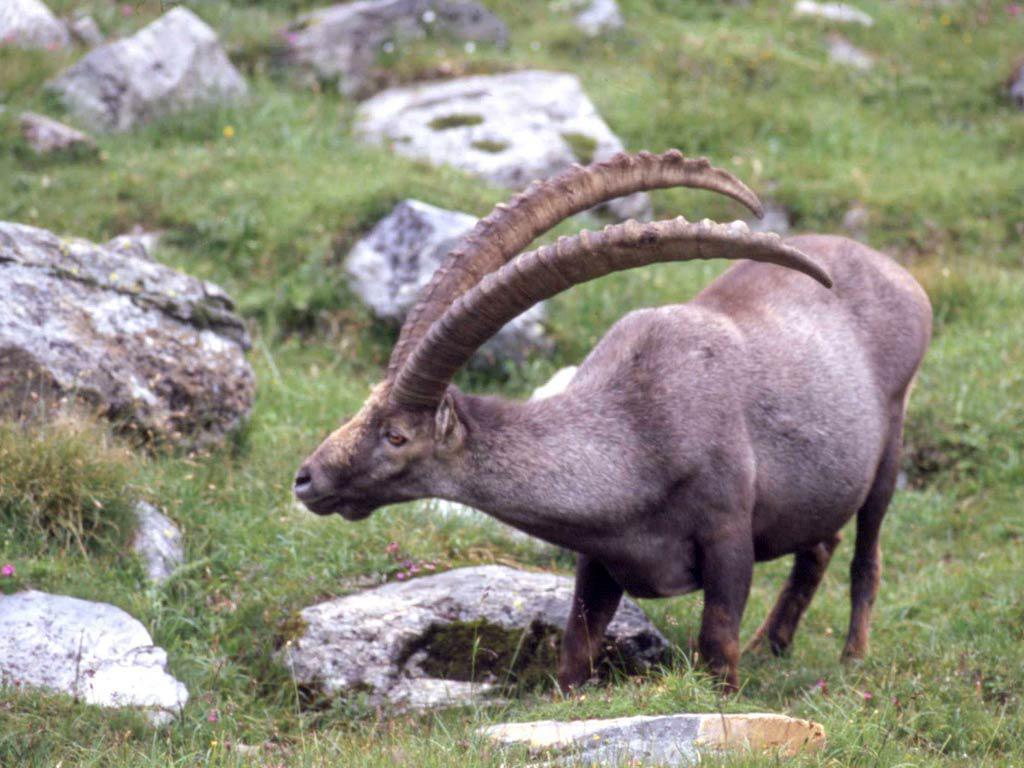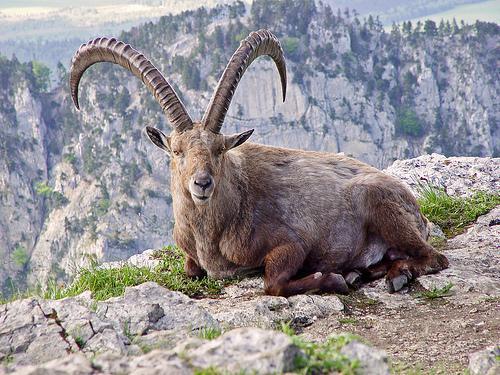The first image is the image on the left, the second image is the image on the right. For the images shown, is this caption "At least one image shows a horned animal resting on the ground with feet visible, tucked underneath." true? Answer yes or no. Yes. 